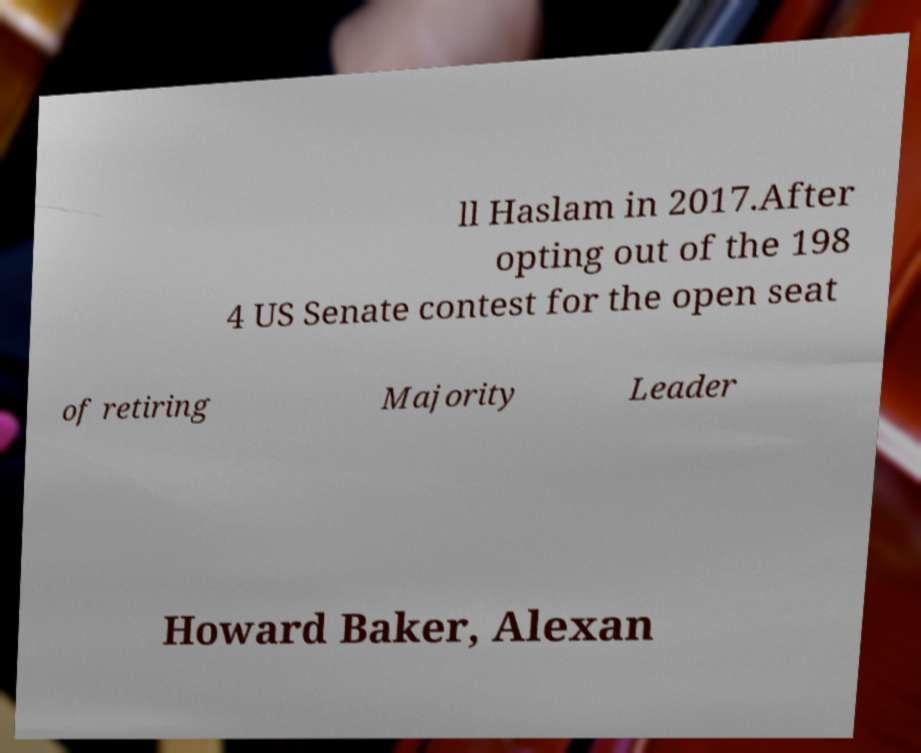What messages or text are displayed in this image? I need them in a readable, typed format. ll Haslam in 2017.After opting out of the 198 4 US Senate contest for the open seat of retiring Majority Leader Howard Baker, Alexan 